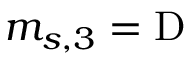<formula> <loc_0><loc_0><loc_500><loc_500>m _ { s , 3 } = D</formula> 